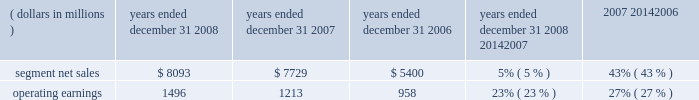The segment had operating earnings of $ 709 million in 2007 , compared to operating earnings of $ 787 million in 2006 .
The decrease in operating earnings was primarily due to a decrease in gross margin , driven by : ( i ) lower net sales of iden infrastructure equipment , and ( ii ) continued competitive pricing pressure in the market for gsm infrastructure equipment , partially offset by : ( i ) increased net sales of digital entertainment devices , and ( ii ) the reversal of reorganization of business accruals recorded in 2006 relating to employee severance which were no longer needed .
Sg&a expenses increased primarily due to the expenses from recently acquired businesses , partially offset by savings from cost-reduction initiatives .
R&d expenditures decreased primarily due to savings from cost- reduction initiatives , partially offset by expenditures by recently acquired businesses and continued investment in digital entertainment devices and wimax .
As a percentage of net sales in 2007 as compared to 2006 , gross margin , sg&a expenses , r&d expenditures and operating margin all decreased .
In 2007 , sales to the segment 2019s top five customers represented approximately 43% ( 43 % ) of the segment 2019s net sales .
The segment 2019s backlog was $ 2.6 billion at december 31 , 2007 , compared to $ 3.2 billion at december 31 , 2006 .
In the home business , demand for the segment 2019s products depends primarily on the level of capital spending by broadband operators for constructing , rebuilding or upgrading their communications systems , and for offering advanced services .
During the second quarter of 2007 , the segment began shipping digital set-tops that support the federal communications commission ( 201cfcc 201d ) 2014 mandated separable security requirement .
Fcc regulations mandating the separation of security functionality from set-tops went into effect on july 1 , 2007 .
As a result of these regulations , many cable service providers accelerated their purchases of set-tops in the first half of 2007 .
Additionally , in 2007 , our digital video customers significantly increased their purchases of the segment 2019s products and services , primarily due to increased demand for digital entertainment devices , particularly hd/dvr devices .
During 2007 , the segment completed the acquisitions of : ( i ) netopia , inc. , a broadband equipment provider for dsl customers , which allows for phone , tv and fast internet connections , ( ii ) tut systems , inc. , a leading developer of edge routing and video encoders , ( iii ) modulus video , inc. , a provider of mpeg-4 advanced coding compression systems designed for delivery of high-value video content in ip set-top devices for the digital video , broadcast and satellite marketplaces , ( iv ) terayon communication systems , inc. , a provider of real-time digital video networking applications to cable , satellite and telecommunication service providers worldwide , and ( v ) leapstone systems , inc. , a provider of intelligent multimedia service delivery and content management applications to networks operators .
These acquisitions enhance our ability to provide complete end-to-end systems for the delivery of advanced video , voice and data services .
In december 2007 , motorola completed the sale of ecc to emerson for $ 346 million in cash .
Enterprise mobility solutions segment the enterprise mobility solutions segment designs , manufactures , sells , installs and services analog and digital two-way radio , voice and data communications products and systems for private networks , wireless broadband systems and end-to-end enterprise mobility solutions to a wide range of enterprise markets , including government and public safety agencies ( which , together with all sales to distributors of two-way communication products , are referred to as the 201cgovernment and public safety market 201d ) , as well as retail , energy and utilities , transportation , manufacturing , healthcare and other commercial customers ( which , collectively , are referred to as the 201ccommercial enterprise market 201d ) .
In 2008 , the segment 2019s net sales represented 27% ( 27 % ) of the company 2019s consolidated net sales , compared to 21% ( 21 % ) in 2007 and 13% ( 13 % ) in 2006 .
( dollars in millions ) 2008 2007 2006 2008 20142007 2007 20142006 years ended december 31 percent change .
Segment results 20142008 compared to 2007 in 2008 , the segment 2019s net sales increased 5% ( 5 % ) to $ 8.1 billion , compared to $ 7.7 billion in 2007 .
The 5% ( 5 % ) increase in net sales reflects an 8% ( 8 % ) increase in net sales to the government and public safety market , partially offset by a 2% ( 2 % ) decrease in net sales to the commercial enterprise market .
The increase in net sales to the government and public safety market was primarily driven by : ( i ) increased net sales outside of north america , and ( ii ) the net sales generated by vertex standard co. , ltd. , a business the company acquired a controlling interest of in january 2008 , partially offset by lower net sales in north america .
On a geographic basis , the segment 2019s net sales were higher in emea , asia and latin america and lower in north america .
65management 2019s discussion and analysis of financial condition and results of operations %%transmsg*** transmitting job : c49054 pcn : 068000000 ***%%pcmsg|65 |00024|yes|no|02/24/2009 12:31|0|0|page is valid , no graphics -- color : n| .
What was the percentage reduction in the segment 2019s backlog from 2006 to 2007? 
Computations: ((2.6 - 3.2) / 3.2)
Answer: -0.1875. 